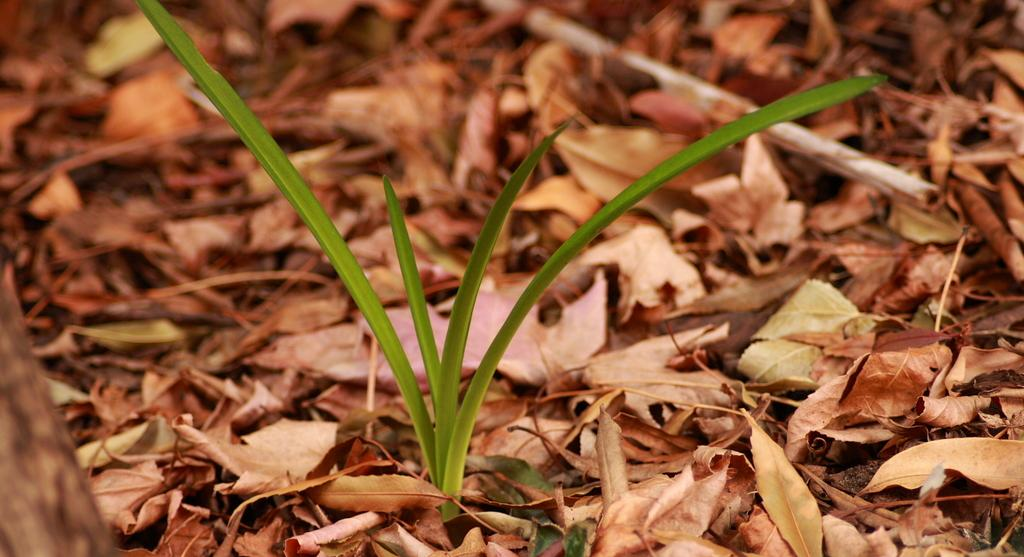What is the main subject of the image? There is a plant in the image. What part of the plant can be seen in the image? Leaves are present in the image. How does the plant wave at passersby in the image? The plant does not wave at passersby in the image; it is stationary. What type of support is the plant using to stand upright in the image? The facts provided do not mention any support for the plant in the image. 